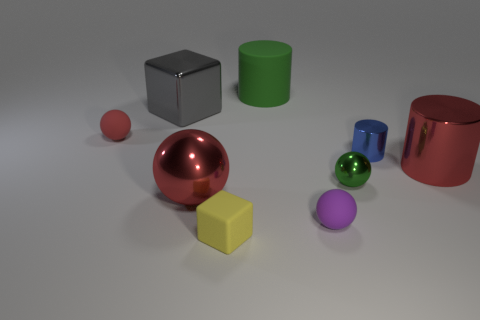There is a block behind the red matte thing; is it the same size as the red metal cylinder?
Offer a terse response. Yes. Is the big metallic cylinder the same color as the large ball?
Give a very brief answer. Yes. How many big cubes are there?
Give a very brief answer. 1. How many cubes are either small brown shiny things or tiny blue metal things?
Your answer should be very brief. 0. How many small objects are behind the large shiny object right of the big red sphere?
Make the answer very short. 2. Are the yellow block and the tiny red thing made of the same material?
Provide a short and direct response. Yes. The other ball that is the same color as the big sphere is what size?
Give a very brief answer. Small. Is there a gray block made of the same material as the red cylinder?
Provide a succinct answer. Yes. There is a big metal object to the left of the big red object to the left of the cylinder on the left side of the purple sphere; what color is it?
Offer a terse response. Gray. How many blue things are either small balls or large blocks?
Make the answer very short. 0. 